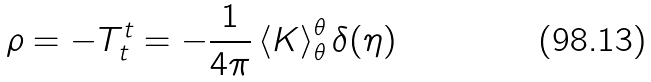<formula> <loc_0><loc_0><loc_500><loc_500>\rho = - T _ { t } ^ { t } = - \frac { 1 } { 4 \pi } \left \langle K \right \rangle _ { \theta } ^ { \theta } \delta ( \eta )</formula> 